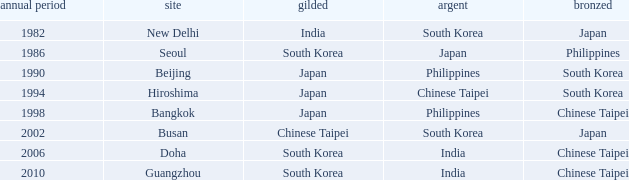Which Location has a Silver of japan? Seoul. 